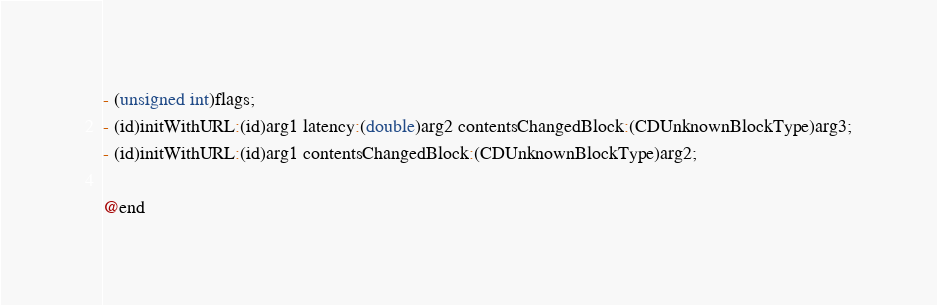Convert code to text. <code><loc_0><loc_0><loc_500><loc_500><_C_>- (unsigned int)flags;
- (id)initWithURL:(id)arg1 latency:(double)arg2 contentsChangedBlock:(CDUnknownBlockType)arg3;
- (id)initWithURL:(id)arg1 contentsChangedBlock:(CDUnknownBlockType)arg2;

@end

</code> 